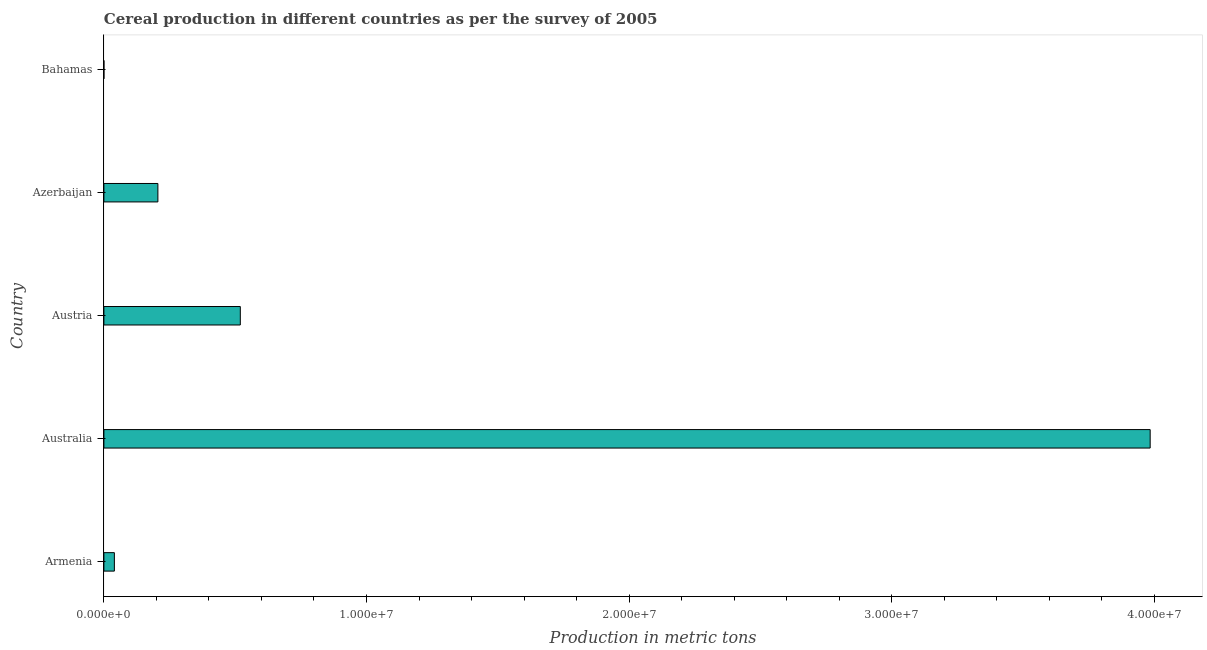Does the graph contain any zero values?
Provide a succinct answer. No. What is the title of the graph?
Your answer should be very brief. Cereal production in different countries as per the survey of 2005. What is the label or title of the X-axis?
Provide a succinct answer. Production in metric tons. What is the label or title of the Y-axis?
Give a very brief answer. Country. What is the cereal production in Bahamas?
Ensure brevity in your answer.  360. Across all countries, what is the maximum cereal production?
Offer a very short reply. 3.98e+07. Across all countries, what is the minimum cereal production?
Ensure brevity in your answer.  360. In which country was the cereal production minimum?
Offer a very short reply. Bahamas. What is the sum of the cereal production?
Your answer should be compact. 4.75e+07. What is the difference between the cereal production in Armenia and Australia?
Your answer should be compact. -3.94e+07. What is the average cereal production per country?
Your answer should be compact. 9.50e+06. What is the median cereal production?
Offer a terse response. 2.06e+06. In how many countries, is the cereal production greater than 24000000 metric tons?
Ensure brevity in your answer.  1. What is the ratio of the cereal production in Australia to that in Bahamas?
Offer a very short reply. 1.11e+05. Is the cereal production in Armenia less than that in Austria?
Make the answer very short. Yes. Is the difference between the cereal production in Armenia and Azerbaijan greater than the difference between any two countries?
Your answer should be very brief. No. What is the difference between the highest and the second highest cereal production?
Give a very brief answer. 3.46e+07. Is the sum of the cereal production in Austria and Azerbaijan greater than the maximum cereal production across all countries?
Provide a succinct answer. No. What is the difference between the highest and the lowest cereal production?
Provide a short and direct response. 3.98e+07. How many bars are there?
Provide a short and direct response. 5. Are all the bars in the graph horizontal?
Your answer should be very brief. Yes. How many countries are there in the graph?
Offer a terse response. 5. Are the values on the major ticks of X-axis written in scientific E-notation?
Your response must be concise. Yes. What is the Production in metric tons of Armenia?
Provide a short and direct response. 3.99e+05. What is the Production in metric tons of Australia?
Give a very brief answer. 3.98e+07. What is the Production in metric tons in Austria?
Make the answer very short. 5.19e+06. What is the Production in metric tons in Azerbaijan?
Your answer should be compact. 2.06e+06. What is the Production in metric tons in Bahamas?
Provide a succinct answer. 360. What is the difference between the Production in metric tons in Armenia and Australia?
Keep it short and to the point. -3.94e+07. What is the difference between the Production in metric tons in Armenia and Austria?
Offer a very short reply. -4.80e+06. What is the difference between the Production in metric tons in Armenia and Azerbaijan?
Make the answer very short. -1.66e+06. What is the difference between the Production in metric tons in Armenia and Bahamas?
Give a very brief answer. 3.99e+05. What is the difference between the Production in metric tons in Australia and Austria?
Ensure brevity in your answer.  3.46e+07. What is the difference between the Production in metric tons in Australia and Azerbaijan?
Ensure brevity in your answer.  3.78e+07. What is the difference between the Production in metric tons in Australia and Bahamas?
Your answer should be compact. 3.98e+07. What is the difference between the Production in metric tons in Austria and Azerbaijan?
Your response must be concise. 3.14e+06. What is the difference between the Production in metric tons in Austria and Bahamas?
Offer a terse response. 5.19e+06. What is the difference between the Production in metric tons in Azerbaijan and Bahamas?
Provide a short and direct response. 2.06e+06. What is the ratio of the Production in metric tons in Armenia to that in Australia?
Your answer should be compact. 0.01. What is the ratio of the Production in metric tons in Armenia to that in Austria?
Give a very brief answer. 0.08. What is the ratio of the Production in metric tons in Armenia to that in Azerbaijan?
Make the answer very short. 0.19. What is the ratio of the Production in metric tons in Armenia to that in Bahamas?
Your answer should be very brief. 1108.8. What is the ratio of the Production in metric tons in Australia to that in Austria?
Provide a short and direct response. 7.67. What is the ratio of the Production in metric tons in Australia to that in Azerbaijan?
Your answer should be compact. 19.38. What is the ratio of the Production in metric tons in Australia to that in Bahamas?
Provide a succinct answer. 1.11e+05. What is the ratio of the Production in metric tons in Austria to that in Azerbaijan?
Offer a very short reply. 2.53. What is the ratio of the Production in metric tons in Austria to that in Bahamas?
Give a very brief answer. 1.44e+04. What is the ratio of the Production in metric tons in Azerbaijan to that in Bahamas?
Make the answer very short. 5711.63. 